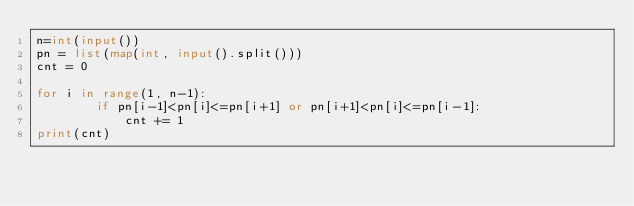<code> <loc_0><loc_0><loc_500><loc_500><_Python_>n=int(input())
pn = list(map(int, input().split()))
cnt = 0

for i in range(1, n-1):
		if pn[i-1]<pn[i]<=pn[i+1] or pn[i+1]<pn[i]<=pn[i-1]:
			cnt += 1
print(cnt)</code> 